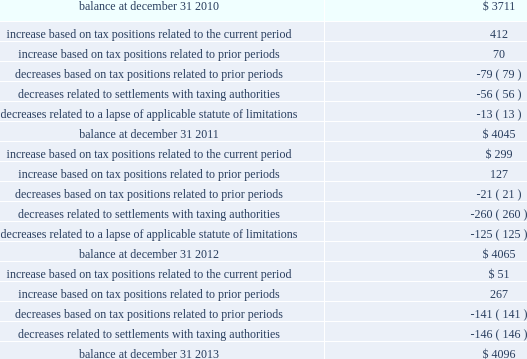Morgan stanley notes to consolidated financial statements 2014 ( continued ) the table presents a reconciliation of the beginning and ending amount of unrecognized tax benefits for 2013 , 2012 and 2011 ( dollars in millions ) : unrecognized tax benefits .
The company is under continuous examination by the irs and other tax authorities in certain countries , such as japan and the u.k. , and in states in which the company has significant business operations , such as new york .
The company is currently under review by the irs appeals office for the remaining issues covering tax years 1999 2013 2005 .
Also , the company is currently at various levels of field examination with respect to audits by the irs , as well as new york state and new york city , for tax years 2006 2013 2008 and 2007 2013 2009 , respectively .
During 2014 , the company expects to reach a conclusion with the u.k .
Tax authorities on substantially all issues through tax year 2010 .
The company believes that the resolution of tax matters will not have a material effect on the consolidated statements of financial condition of the company , although a resolution could have a material impact on the company 2019s consolidated statements of income for a particular future period and on the company 2019s effective income tax rate for any period in which such resolution occurs .
The company has established a liability for unrecognized tax benefits that the company believes is adequate in relation to the potential for additional assessments .
Once established , the company adjusts unrecognized tax benefits only when more information is available or when an event occurs necessitating a change .
The company periodically evaluates the likelihood of assessments in each taxing jurisdiction resulting from the expiration of the applicable statute of limitations or new information regarding the status of current and subsequent years 2019 examinations .
As part of the company 2019s periodic review , federal and state unrecognized tax benefits were released or remeasured .
As a result of this remeasurement , the income tax provision included a discrete tax benefit of $ 161 million and $ 299 million in 2013 and 2012 , respectively .
It is reasonably possible that the gross balance of unrecognized tax benefits of approximately $ 4.1 billion as of december 31 , 2013 may decrease significantly within the next 12 months due to an expected completion of the .
Without settlements in 2013 , what would ending unrecognized tax benefits have been , in millions? 
Computations: (4096 + 146)
Answer: 4242.0. 